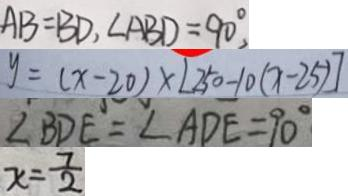Convert formula to latex. <formula><loc_0><loc_0><loc_500><loc_500>A B = B D , \angle A B D = 9 0 ^ { \circ } 
 y = ( x - 2 0 ) \times [ 2 5 0 - 1 0 ( x - 2 5 ) ] 
 \angle B D E = \angle A D E = 9 0 ^ { \circ } 
 x = \frac { 7 } { 2 }</formula> 